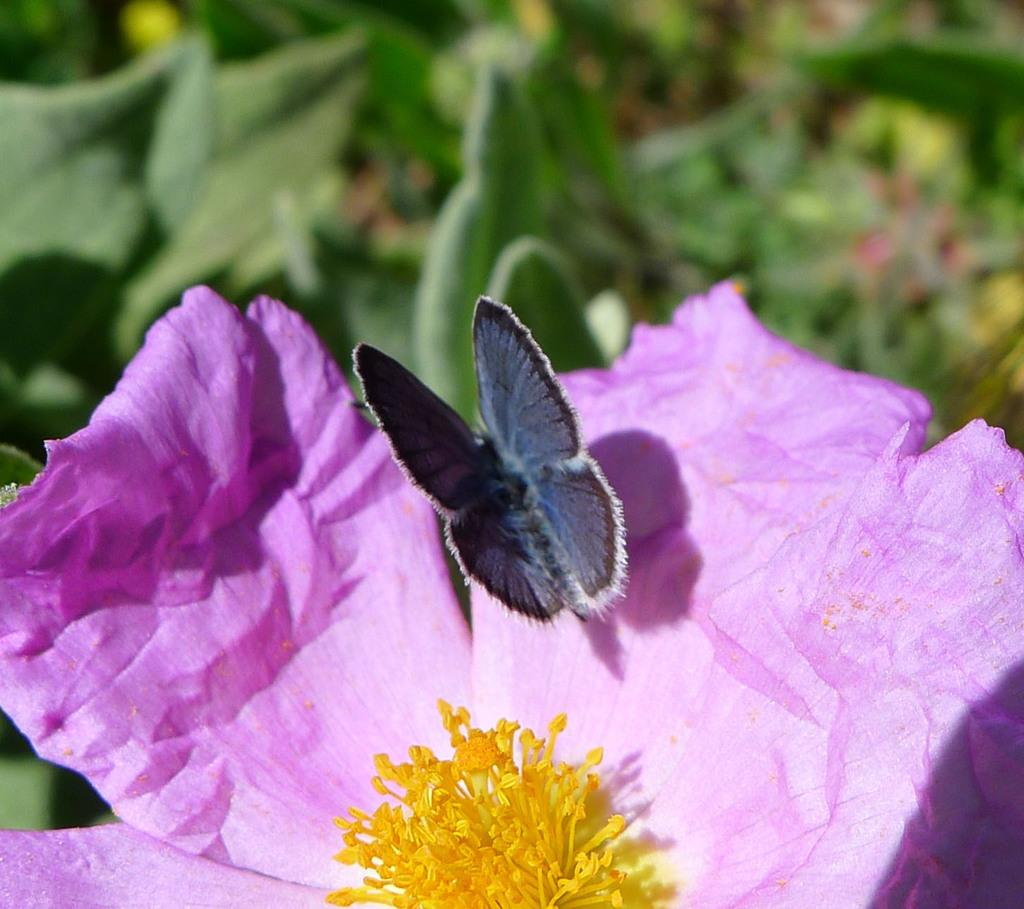What color is the flower in the image? The flower in the image is violet-colored. What is on the petal of the flower? A butterfly is present on the petal of the flower. What other plant elements can be seen in the image? There are plants with leaves visible in the image. What type of bread can be seen in the image? There is no bread present in the image; it features a violet-colored flower with a butterfly on its petal and other plants with leaves. 